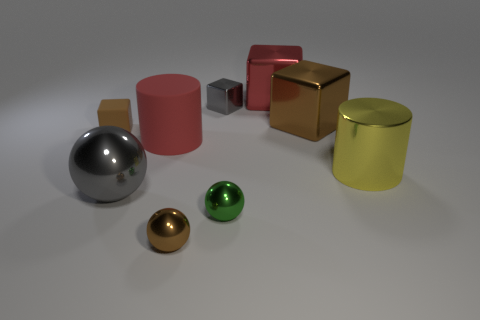The metal thing that is the same color as the tiny shiny cube is what size?
Provide a succinct answer. Large. There is a small block that is to the right of the brown object on the left side of the large matte thing; what color is it?
Your response must be concise. Gray. Is there a metal thing that has the same color as the tiny rubber thing?
Your response must be concise. Yes. There is a sphere that is the same size as the red matte cylinder; what color is it?
Your response must be concise. Gray. Are the big red object to the left of the large red cube and the tiny green object made of the same material?
Offer a terse response. No. Are there any brown metal spheres to the left of the brown metal object that is behind the rubber thing in front of the tiny matte cube?
Give a very brief answer. Yes. There is a brown shiny thing behind the big yellow shiny cylinder; does it have the same shape as the big red shiny object?
Offer a very short reply. Yes. What shape is the rubber thing that is on the left side of the red object on the left side of the small gray object?
Provide a short and direct response. Cube. What size is the brown thing that is in front of the large shiny cylinder that is on the right side of the brown block that is in front of the large brown metallic block?
Give a very brief answer. Small. There is another tiny thing that is the same shape as the tiny green object; what is its color?
Keep it short and to the point. Brown. 